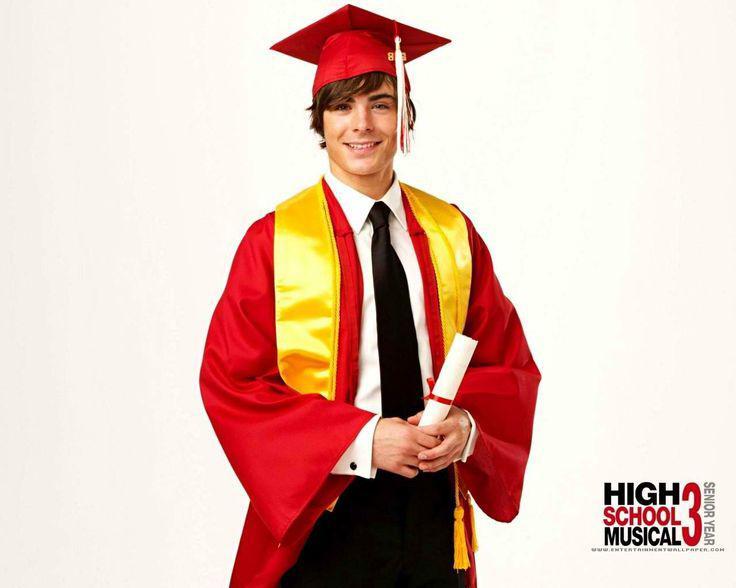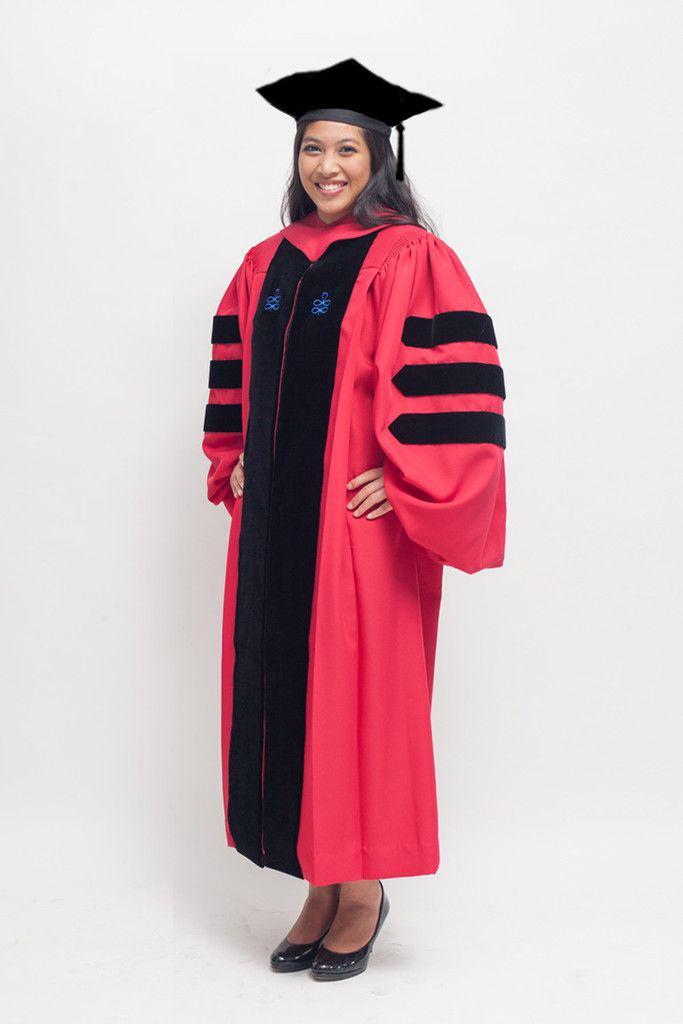The first image is the image on the left, the second image is the image on the right. Evaluate the accuracy of this statement regarding the images: "There are two images of people wearing graduation caps that have tassels hanging to the right.". Is it true? Answer yes or no. Yes. The first image is the image on the left, the second image is the image on the right. Analyze the images presented: Is the assertion "The image on the left shows a student in graduation attire holding a diploma in their hands." valid? Answer yes or no. Yes. 